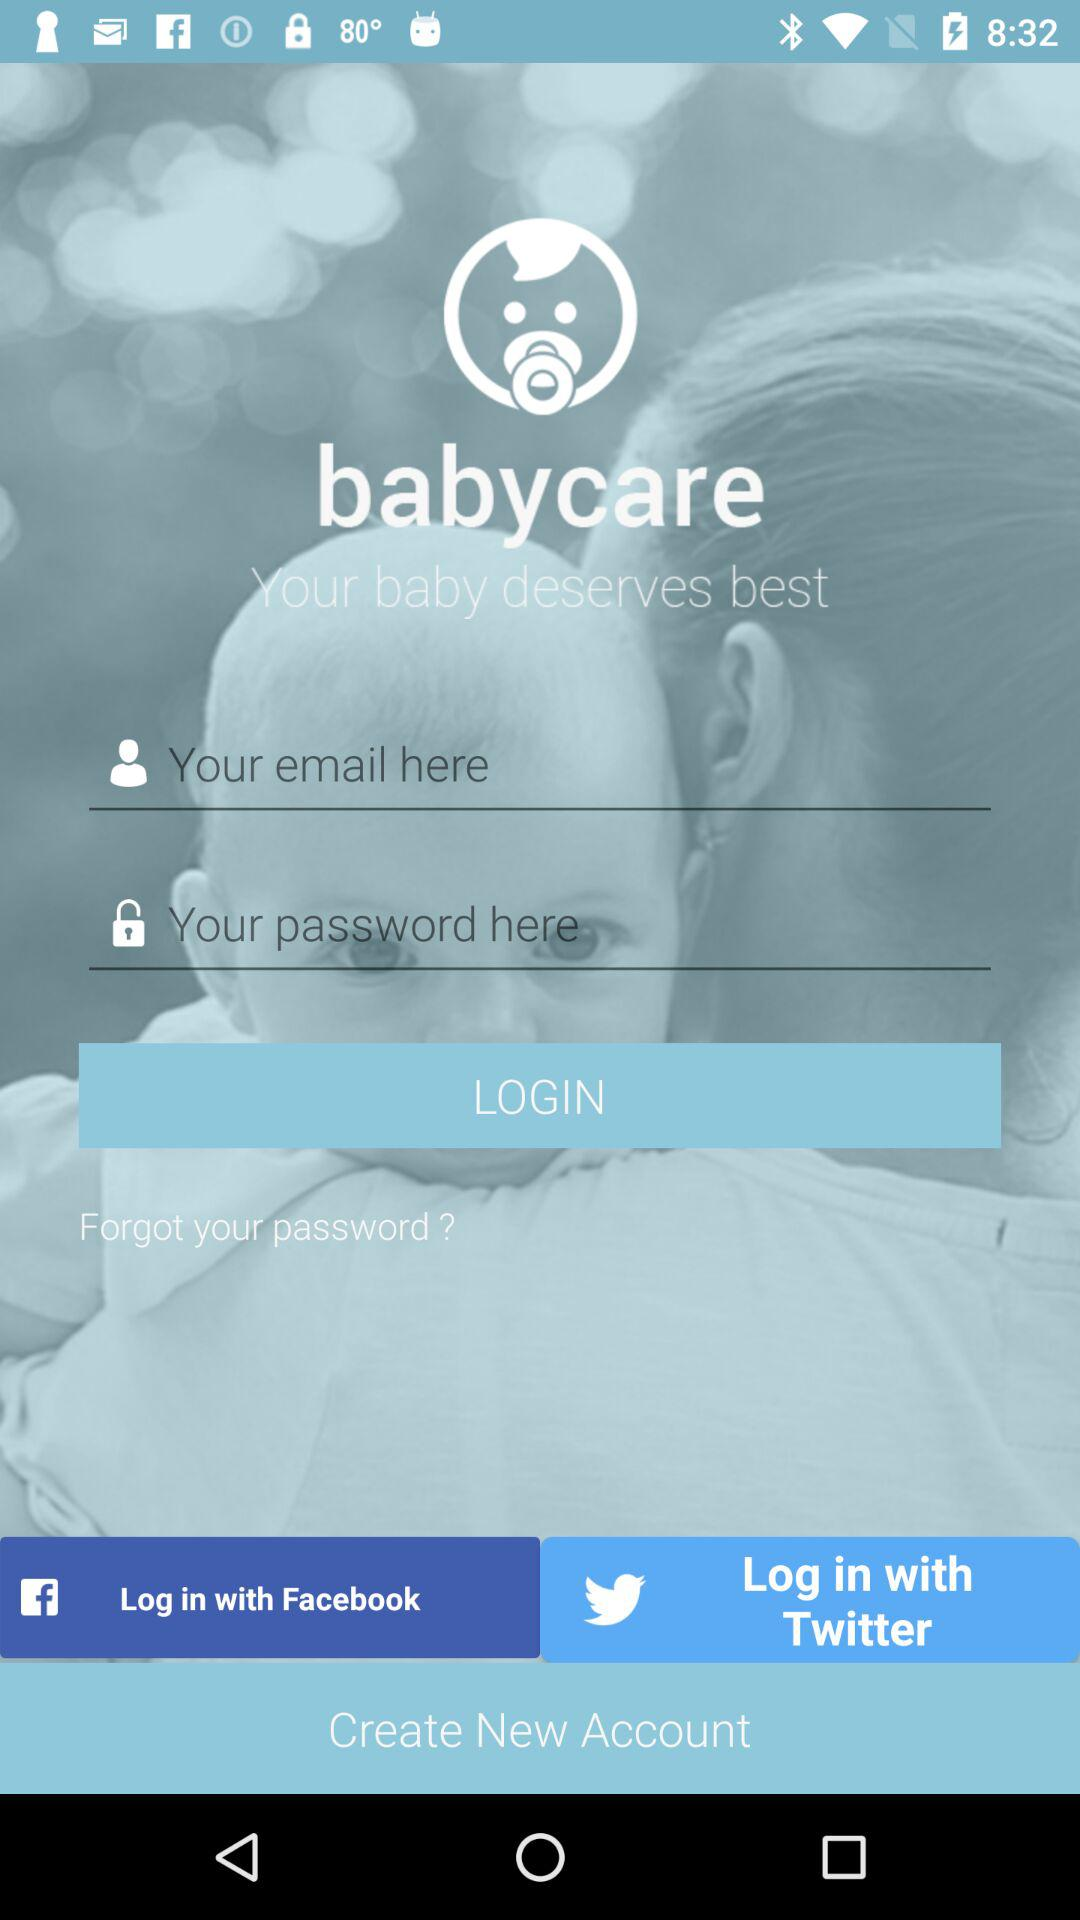How many characters are required to create a password?
When the provided information is insufficient, respond with <no answer>. <no answer> 